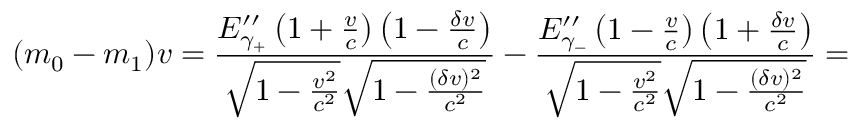<formula> <loc_0><loc_0><loc_500><loc_500>( m _ { 0 } - m _ { 1 } ) v = \frac { E _ { \gamma _ { + } } ^ { \prime \prime } \left ( 1 + \frac { v } { c } \right ) \left ( 1 - \frac { \delta v } { c } \right ) } { \sqrt { 1 - \frac { v ^ { 2 } } { c ^ { 2 } } } \sqrt { 1 - \frac { ( \delta v ) ^ { 2 } } { c ^ { 2 } } } } - \frac { E _ { \gamma _ { - } } ^ { \prime \prime } \left ( 1 - \frac { v } { c } \right ) \left ( 1 + \frac { \delta v } { c } \right ) } { \sqrt { 1 - \frac { v ^ { 2 } } { c ^ { 2 } } } \sqrt { 1 - \frac { ( \delta v ) ^ { 2 } } { c ^ { 2 } } } } =</formula> 